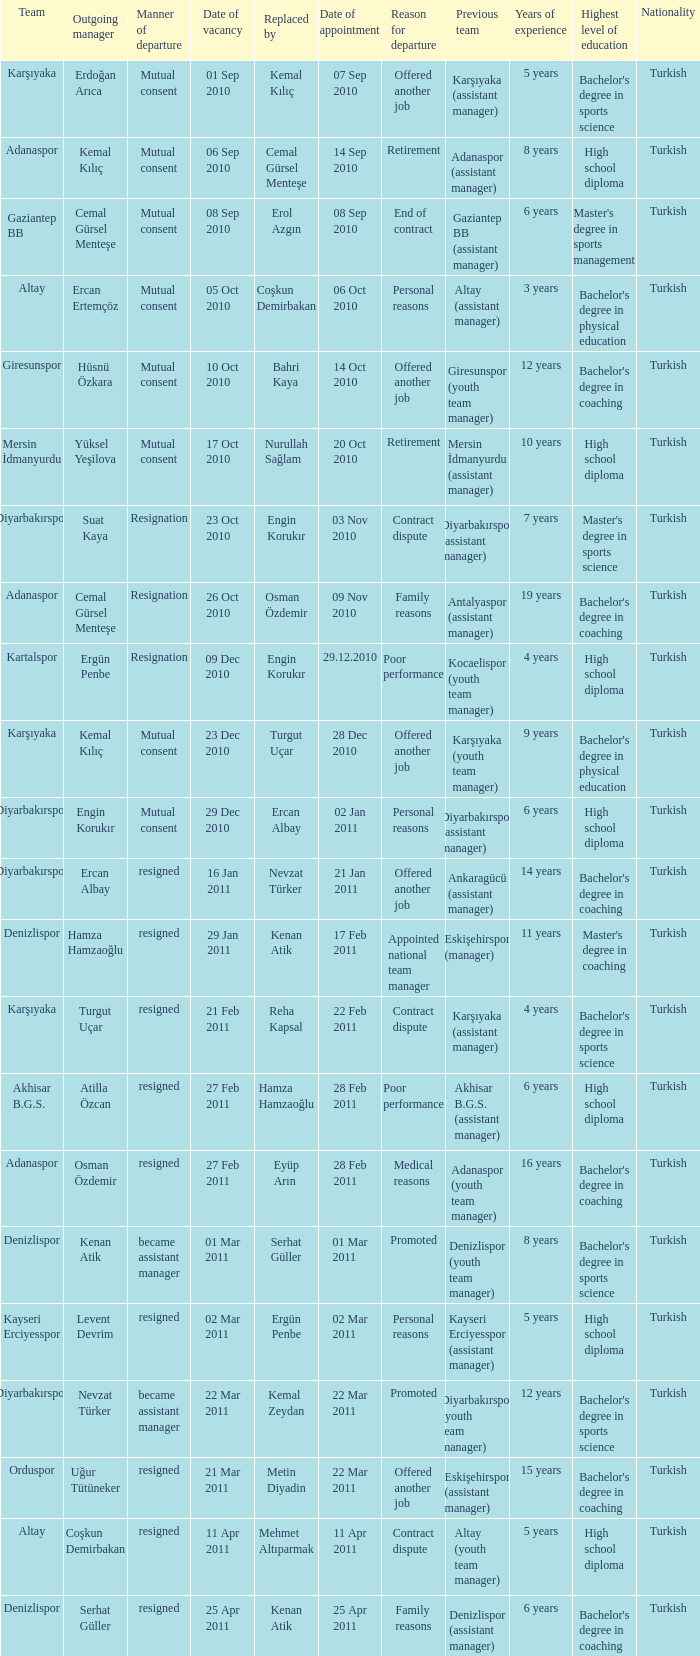Which team replaced their manager with Serhat Güller? Denizlispor. 